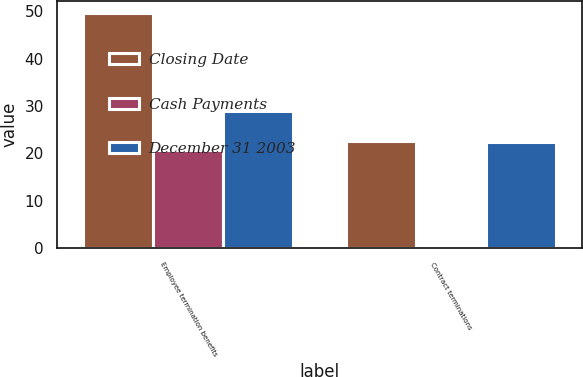Convert chart. <chart><loc_0><loc_0><loc_500><loc_500><stacked_bar_chart><ecel><fcel>Employee termination benefits<fcel>Contract terminations<nl><fcel>Closing Date<fcel>49.7<fcel>22.6<nl><fcel>Cash Payments<fcel>20.7<fcel>0.2<nl><fcel>December 31 2003<fcel>29<fcel>22.4<nl></chart> 